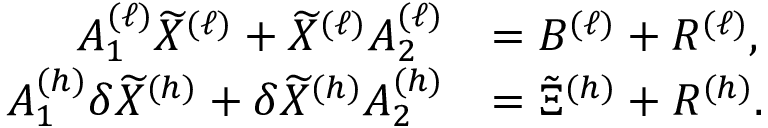<formula> <loc_0><loc_0><loc_500><loc_500>\begin{array} { r l } { A _ { 1 } ^ { ( \ell ) } \widetilde { X } ^ { ( \ell ) } + \widetilde { X } ^ { ( \ell ) } A _ { 2 } ^ { ( \ell ) } } & { = B ^ { ( \ell ) } + R ^ { ( \ell ) } , } \\ { A _ { 1 } ^ { ( h ) } \delta \widetilde { X } ^ { ( h ) } + \delta \widetilde { X } ^ { ( h ) } A _ { 2 } ^ { ( h ) } } & { = \tilde { \Xi } ^ { ( h ) } + R ^ { ( h ) } . } \end{array}</formula> 